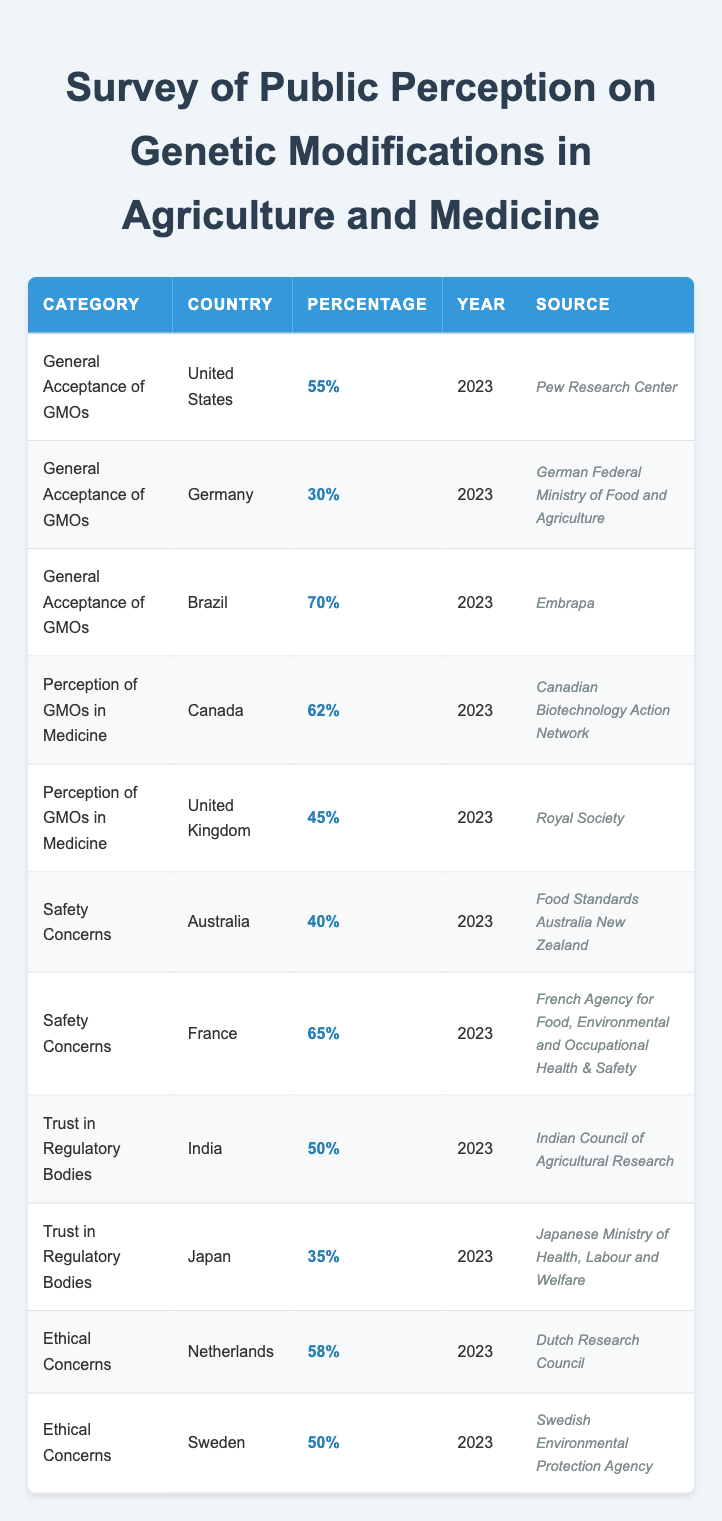What is the percentage of general acceptance of GMOs in the United States? The table indicates that the percentage of general acceptance of GMOs in the United States is directly listed as 55%.
Answer: 55% Which country has the highest percentage of general acceptance of GMOs? From the table, Brazil has the highest percentage listed for general acceptance at 70%.
Answer: Brazil What percentage of people in Germany accept GMOs? According to the table, Germany has a general acceptance percentage of 30%.
Answer: 30% What is the average percentage of acceptance for GMOs in Canada and the United Kingdom? The acceptance in Canada is 62%, and in the United Kingdom, it is 45%. To find the average: (62 + 45) / 2 = 53.5%.
Answer: 53.5% Is it true that Australia has a higher percentage of safety concerns compared to France? The table shows that Australia has 40% for safety concerns while France has 65%. Therefore, it is false that Australia has a higher percentage than France.
Answer: No Which country reports the lowest trust in regulatory bodies? The table lists Japan with a trust percentage of 35%, which is lower than India's 50%. Thus, Japan reports the lowest trust among the listed countries.
Answer: Japan What is the difference in the percentage of ethical concerns between the Netherlands and Sweden? The Netherlands has 58% and Sweden has 50%. To find the difference: 58 - 50 = 8%.
Answer: 8% How does the perception of GMOs in medicine in Canada compare to that in the United Kingdom? Canada has a perception percentage of 62% while the United Kingdom has 45%. Therefore, the perception in Canada is higher by 17%.
Answer: 17% Which category has the highest reported percentage overall, across all countries listed? The maximum percentage in the table is 70% for the category of general acceptance of GMOs in Brazil, which is the highest overall.
Answer: General Acceptance of GMOs in Brazil 70% 